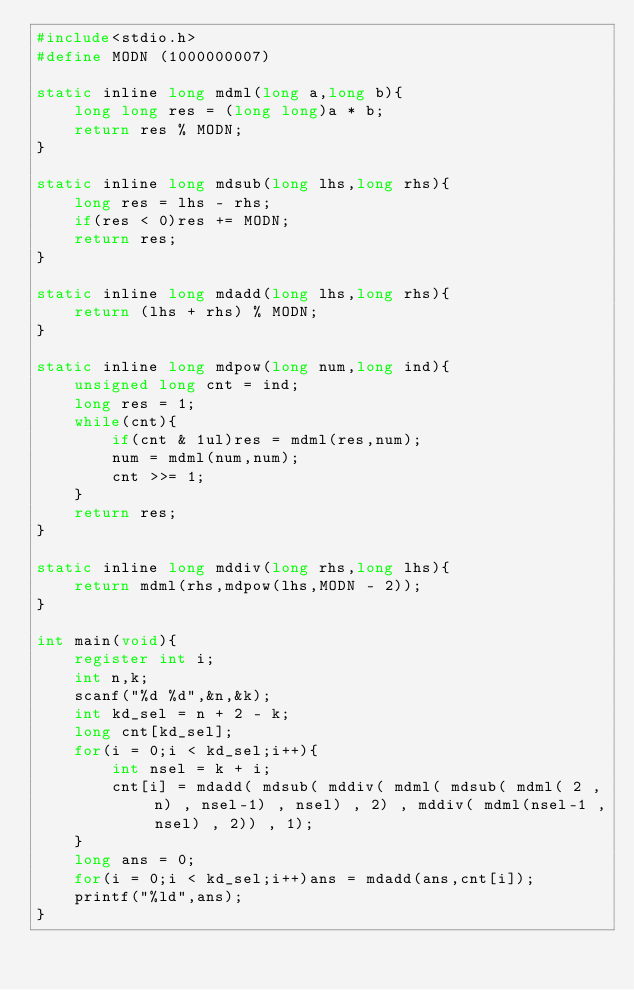<code> <loc_0><loc_0><loc_500><loc_500><_C_>#include<stdio.h>
#define MODN (1000000007)

static inline long mdml(long a,long b){
    long long res = (long long)a * b;
    return res % MODN;
}

static inline long mdsub(long lhs,long rhs){
    long res = lhs - rhs;
    if(res < 0)res += MODN;
    return res;
}

static inline long mdadd(long lhs,long rhs){
    return (lhs + rhs) % MODN;
}

static inline long mdpow(long num,long ind){
    unsigned long cnt = ind;
    long res = 1;  
    while(cnt){
        if(cnt & 1ul)res = mdml(res,num);
        num = mdml(num,num);
        cnt >>= 1;
    }
    return res;
}

static inline long mddiv(long rhs,long lhs){
    return mdml(rhs,mdpow(lhs,MODN - 2));
}

int main(void){
    register int i;
    int n,k;
    scanf("%d %d",&n,&k);
    int kd_sel = n + 2 - k;
    long cnt[kd_sel];
    for(i = 0;i < kd_sel;i++){
        int nsel = k + i;
        cnt[i] = mdadd( mdsub( mddiv( mdml( mdsub( mdml( 2 , n) , nsel-1) , nsel) , 2) , mddiv( mdml(nsel-1 , nsel) , 2)) , 1);
    }
    long ans = 0;
    for(i = 0;i < kd_sel;i++)ans = mdadd(ans,cnt[i]);
    printf("%ld",ans);
}</code> 